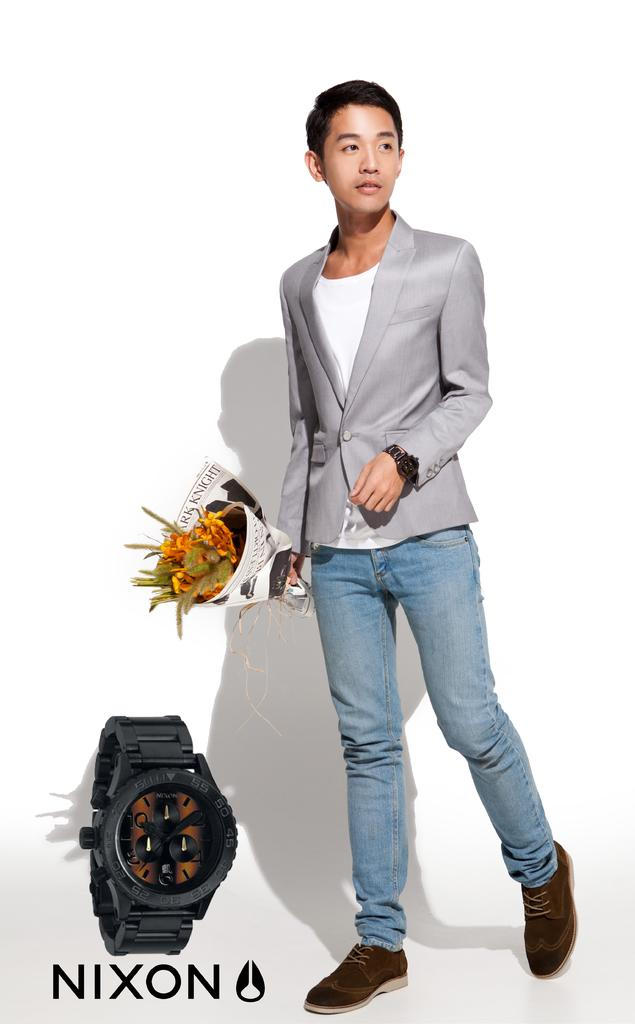<image>
Describe the image concisely. The brand name of the watch is "NIXON." 